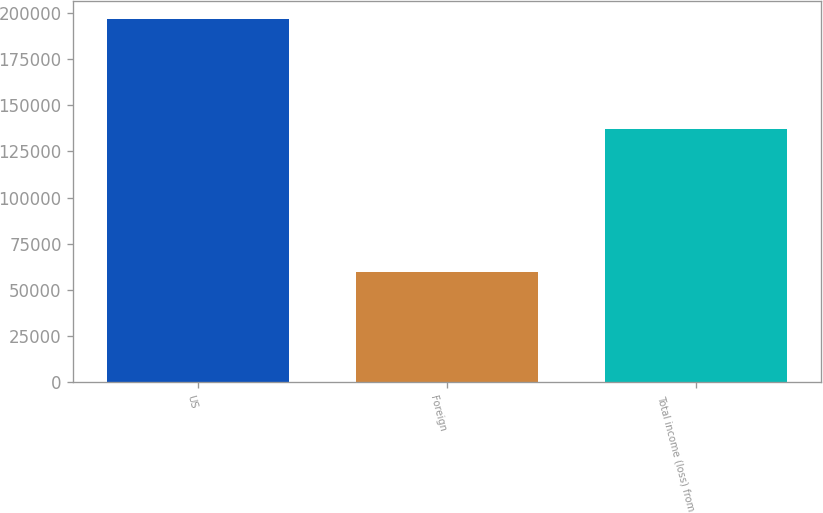Convert chart. <chart><loc_0><loc_0><loc_500><loc_500><bar_chart><fcel>US<fcel>Foreign<fcel>Total income (loss) from<nl><fcel>196696<fcel>59585<fcel>137111<nl></chart> 